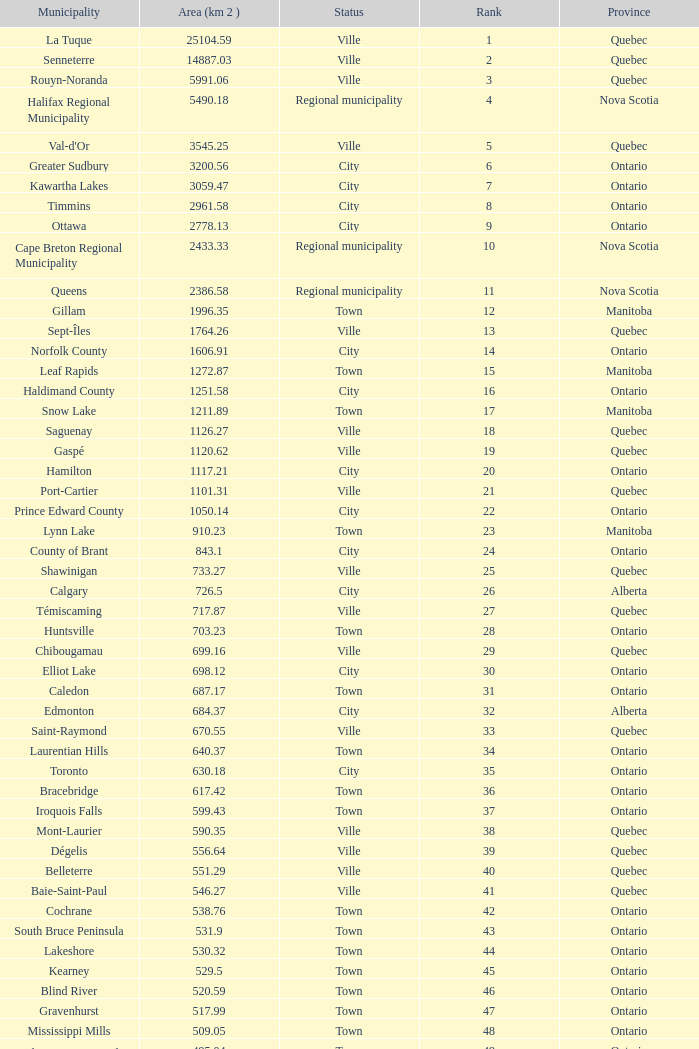What's the total of Rank that has an Area (KM 2) of 1050.14? 22.0. 